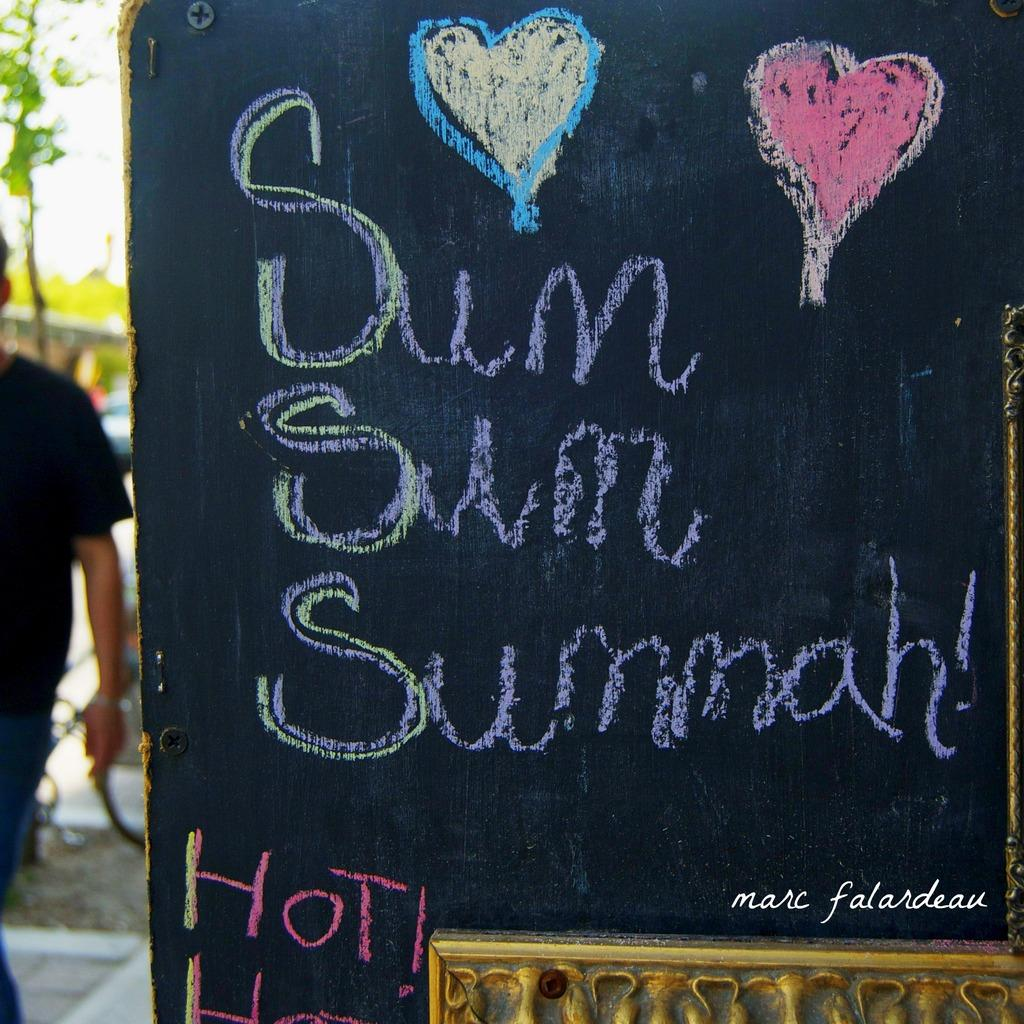Where is the man located in the image? The man is standing in the bottom left side of the image. What is visible behind the man? There are trees and vehicles behind the man. What is located in the bottom right side of the image? There is a banner in the bottom right side of the image. What type of science is being conducted on the roof in the image? There is no roof or science activity present in the image. 